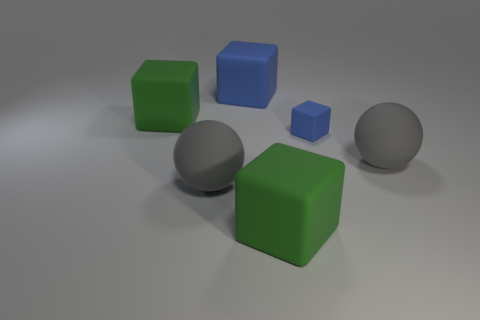Subtract all blocks. How many objects are left? 2 Add 3 large green blocks. How many objects exist? 9 Subtract all big blue blocks. How many blocks are left? 3 Add 1 large green cubes. How many large green cubes exist? 3 Subtract all green cubes. How many cubes are left? 2 Subtract 0 gray blocks. How many objects are left? 6 Subtract 2 spheres. How many spheres are left? 0 Subtract all cyan cubes. Subtract all red spheres. How many cubes are left? 4 Subtract all yellow balls. How many green blocks are left? 2 Subtract all blocks. Subtract all big gray objects. How many objects are left? 0 